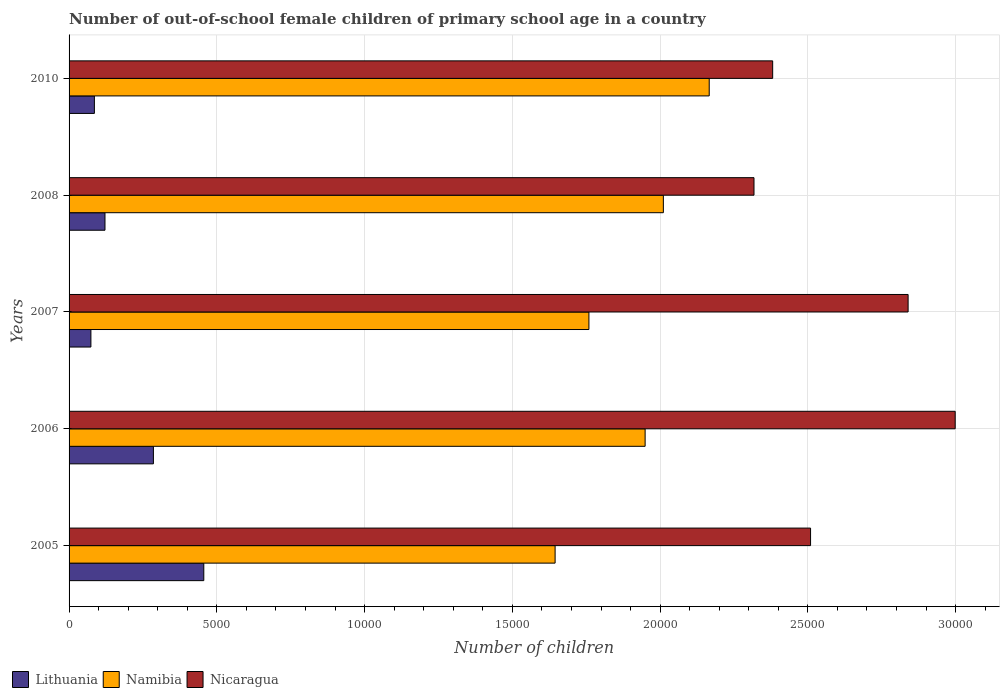How many different coloured bars are there?
Offer a very short reply. 3. Are the number of bars per tick equal to the number of legend labels?
Your response must be concise. Yes. How many bars are there on the 1st tick from the bottom?
Your answer should be compact. 3. What is the label of the 1st group of bars from the top?
Offer a very short reply. 2010. What is the number of out-of-school female children in Nicaragua in 2007?
Your answer should be very brief. 2.84e+04. Across all years, what is the maximum number of out-of-school female children in Lithuania?
Your answer should be compact. 4559. Across all years, what is the minimum number of out-of-school female children in Nicaragua?
Give a very brief answer. 2.32e+04. In which year was the number of out-of-school female children in Lithuania maximum?
Offer a very short reply. 2005. What is the total number of out-of-school female children in Namibia in the graph?
Ensure brevity in your answer.  9.53e+04. What is the difference between the number of out-of-school female children in Namibia in 2005 and that in 2010?
Give a very brief answer. -5215. What is the difference between the number of out-of-school female children in Namibia in 2010 and the number of out-of-school female children in Lithuania in 2005?
Your response must be concise. 1.71e+04. What is the average number of out-of-school female children in Lithuania per year?
Ensure brevity in your answer.  2044.8. In the year 2010, what is the difference between the number of out-of-school female children in Nicaragua and number of out-of-school female children in Lithuania?
Provide a succinct answer. 2.30e+04. What is the ratio of the number of out-of-school female children in Nicaragua in 2005 to that in 2010?
Provide a short and direct response. 1.05. What is the difference between the highest and the second highest number of out-of-school female children in Lithuania?
Your answer should be compact. 1705. What is the difference between the highest and the lowest number of out-of-school female children in Lithuania?
Keep it short and to the point. 3820. In how many years, is the number of out-of-school female children in Lithuania greater than the average number of out-of-school female children in Lithuania taken over all years?
Your answer should be very brief. 2. Is the sum of the number of out-of-school female children in Lithuania in 2005 and 2007 greater than the maximum number of out-of-school female children in Namibia across all years?
Give a very brief answer. No. What does the 1st bar from the top in 2006 represents?
Your answer should be very brief. Nicaragua. What does the 3rd bar from the bottom in 2008 represents?
Provide a succinct answer. Nicaragua. Are all the bars in the graph horizontal?
Your answer should be compact. Yes. What is the difference between two consecutive major ticks on the X-axis?
Your answer should be very brief. 5000. Are the values on the major ticks of X-axis written in scientific E-notation?
Offer a terse response. No. How many legend labels are there?
Offer a terse response. 3. What is the title of the graph?
Offer a very short reply. Number of out-of-school female children of primary school age in a country. Does "Gabon" appear as one of the legend labels in the graph?
Keep it short and to the point. No. What is the label or title of the X-axis?
Provide a short and direct response. Number of children. What is the label or title of the Y-axis?
Provide a succinct answer. Years. What is the Number of children in Lithuania in 2005?
Your answer should be very brief. 4559. What is the Number of children in Namibia in 2005?
Give a very brief answer. 1.64e+04. What is the Number of children in Nicaragua in 2005?
Offer a very short reply. 2.51e+04. What is the Number of children in Lithuania in 2006?
Ensure brevity in your answer.  2854. What is the Number of children in Namibia in 2006?
Make the answer very short. 1.95e+04. What is the Number of children in Nicaragua in 2006?
Offer a terse response. 3.00e+04. What is the Number of children in Lithuania in 2007?
Keep it short and to the point. 739. What is the Number of children of Namibia in 2007?
Give a very brief answer. 1.76e+04. What is the Number of children of Nicaragua in 2007?
Provide a short and direct response. 2.84e+04. What is the Number of children in Lithuania in 2008?
Ensure brevity in your answer.  1215. What is the Number of children in Namibia in 2008?
Provide a succinct answer. 2.01e+04. What is the Number of children of Nicaragua in 2008?
Offer a very short reply. 2.32e+04. What is the Number of children of Lithuania in 2010?
Give a very brief answer. 857. What is the Number of children in Namibia in 2010?
Provide a succinct answer. 2.17e+04. What is the Number of children in Nicaragua in 2010?
Your answer should be compact. 2.38e+04. Across all years, what is the maximum Number of children in Lithuania?
Provide a short and direct response. 4559. Across all years, what is the maximum Number of children in Namibia?
Your answer should be compact. 2.17e+04. Across all years, what is the maximum Number of children in Nicaragua?
Offer a very short reply. 3.00e+04. Across all years, what is the minimum Number of children of Lithuania?
Ensure brevity in your answer.  739. Across all years, what is the minimum Number of children of Namibia?
Your answer should be compact. 1.64e+04. Across all years, what is the minimum Number of children of Nicaragua?
Offer a terse response. 2.32e+04. What is the total Number of children in Lithuania in the graph?
Your answer should be compact. 1.02e+04. What is the total Number of children in Namibia in the graph?
Provide a succinct answer. 9.53e+04. What is the total Number of children of Nicaragua in the graph?
Ensure brevity in your answer.  1.30e+05. What is the difference between the Number of children of Lithuania in 2005 and that in 2006?
Keep it short and to the point. 1705. What is the difference between the Number of children in Namibia in 2005 and that in 2006?
Make the answer very short. -3046. What is the difference between the Number of children of Nicaragua in 2005 and that in 2006?
Offer a very short reply. -4894. What is the difference between the Number of children in Lithuania in 2005 and that in 2007?
Provide a succinct answer. 3820. What is the difference between the Number of children in Namibia in 2005 and that in 2007?
Give a very brief answer. -1144. What is the difference between the Number of children in Nicaragua in 2005 and that in 2007?
Your answer should be compact. -3301. What is the difference between the Number of children in Lithuania in 2005 and that in 2008?
Make the answer very short. 3344. What is the difference between the Number of children in Namibia in 2005 and that in 2008?
Your answer should be very brief. -3663. What is the difference between the Number of children of Nicaragua in 2005 and that in 2008?
Provide a short and direct response. 1914. What is the difference between the Number of children in Lithuania in 2005 and that in 2010?
Your answer should be very brief. 3702. What is the difference between the Number of children of Namibia in 2005 and that in 2010?
Make the answer very short. -5215. What is the difference between the Number of children of Nicaragua in 2005 and that in 2010?
Give a very brief answer. 1282. What is the difference between the Number of children of Lithuania in 2006 and that in 2007?
Provide a succinct answer. 2115. What is the difference between the Number of children of Namibia in 2006 and that in 2007?
Keep it short and to the point. 1902. What is the difference between the Number of children in Nicaragua in 2006 and that in 2007?
Make the answer very short. 1593. What is the difference between the Number of children of Lithuania in 2006 and that in 2008?
Your response must be concise. 1639. What is the difference between the Number of children in Namibia in 2006 and that in 2008?
Give a very brief answer. -617. What is the difference between the Number of children of Nicaragua in 2006 and that in 2008?
Give a very brief answer. 6808. What is the difference between the Number of children in Lithuania in 2006 and that in 2010?
Your answer should be very brief. 1997. What is the difference between the Number of children of Namibia in 2006 and that in 2010?
Keep it short and to the point. -2169. What is the difference between the Number of children in Nicaragua in 2006 and that in 2010?
Ensure brevity in your answer.  6176. What is the difference between the Number of children of Lithuania in 2007 and that in 2008?
Provide a short and direct response. -476. What is the difference between the Number of children of Namibia in 2007 and that in 2008?
Make the answer very short. -2519. What is the difference between the Number of children of Nicaragua in 2007 and that in 2008?
Keep it short and to the point. 5215. What is the difference between the Number of children of Lithuania in 2007 and that in 2010?
Your answer should be compact. -118. What is the difference between the Number of children of Namibia in 2007 and that in 2010?
Make the answer very short. -4071. What is the difference between the Number of children of Nicaragua in 2007 and that in 2010?
Your answer should be compact. 4583. What is the difference between the Number of children in Lithuania in 2008 and that in 2010?
Keep it short and to the point. 358. What is the difference between the Number of children in Namibia in 2008 and that in 2010?
Keep it short and to the point. -1552. What is the difference between the Number of children in Nicaragua in 2008 and that in 2010?
Provide a succinct answer. -632. What is the difference between the Number of children of Lithuania in 2005 and the Number of children of Namibia in 2006?
Your answer should be very brief. -1.49e+04. What is the difference between the Number of children of Lithuania in 2005 and the Number of children of Nicaragua in 2006?
Offer a terse response. -2.54e+04. What is the difference between the Number of children of Namibia in 2005 and the Number of children of Nicaragua in 2006?
Provide a succinct answer. -1.35e+04. What is the difference between the Number of children of Lithuania in 2005 and the Number of children of Namibia in 2007?
Keep it short and to the point. -1.30e+04. What is the difference between the Number of children of Lithuania in 2005 and the Number of children of Nicaragua in 2007?
Make the answer very short. -2.38e+04. What is the difference between the Number of children of Namibia in 2005 and the Number of children of Nicaragua in 2007?
Ensure brevity in your answer.  -1.19e+04. What is the difference between the Number of children of Lithuania in 2005 and the Number of children of Namibia in 2008?
Offer a terse response. -1.56e+04. What is the difference between the Number of children of Lithuania in 2005 and the Number of children of Nicaragua in 2008?
Keep it short and to the point. -1.86e+04. What is the difference between the Number of children of Namibia in 2005 and the Number of children of Nicaragua in 2008?
Make the answer very short. -6730. What is the difference between the Number of children of Lithuania in 2005 and the Number of children of Namibia in 2010?
Keep it short and to the point. -1.71e+04. What is the difference between the Number of children of Lithuania in 2005 and the Number of children of Nicaragua in 2010?
Your answer should be very brief. -1.92e+04. What is the difference between the Number of children in Namibia in 2005 and the Number of children in Nicaragua in 2010?
Provide a succinct answer. -7362. What is the difference between the Number of children of Lithuania in 2006 and the Number of children of Namibia in 2007?
Make the answer very short. -1.47e+04. What is the difference between the Number of children of Lithuania in 2006 and the Number of children of Nicaragua in 2007?
Offer a terse response. -2.55e+04. What is the difference between the Number of children of Namibia in 2006 and the Number of children of Nicaragua in 2007?
Ensure brevity in your answer.  -8899. What is the difference between the Number of children of Lithuania in 2006 and the Number of children of Namibia in 2008?
Offer a terse response. -1.73e+04. What is the difference between the Number of children of Lithuania in 2006 and the Number of children of Nicaragua in 2008?
Provide a succinct answer. -2.03e+04. What is the difference between the Number of children in Namibia in 2006 and the Number of children in Nicaragua in 2008?
Provide a succinct answer. -3684. What is the difference between the Number of children of Lithuania in 2006 and the Number of children of Namibia in 2010?
Make the answer very short. -1.88e+04. What is the difference between the Number of children of Lithuania in 2006 and the Number of children of Nicaragua in 2010?
Give a very brief answer. -2.10e+04. What is the difference between the Number of children in Namibia in 2006 and the Number of children in Nicaragua in 2010?
Provide a short and direct response. -4316. What is the difference between the Number of children in Lithuania in 2007 and the Number of children in Namibia in 2008?
Your response must be concise. -1.94e+04. What is the difference between the Number of children in Lithuania in 2007 and the Number of children in Nicaragua in 2008?
Offer a terse response. -2.24e+04. What is the difference between the Number of children of Namibia in 2007 and the Number of children of Nicaragua in 2008?
Keep it short and to the point. -5586. What is the difference between the Number of children of Lithuania in 2007 and the Number of children of Namibia in 2010?
Make the answer very short. -2.09e+04. What is the difference between the Number of children in Lithuania in 2007 and the Number of children in Nicaragua in 2010?
Ensure brevity in your answer.  -2.31e+04. What is the difference between the Number of children of Namibia in 2007 and the Number of children of Nicaragua in 2010?
Your answer should be compact. -6218. What is the difference between the Number of children of Lithuania in 2008 and the Number of children of Namibia in 2010?
Your response must be concise. -2.04e+04. What is the difference between the Number of children in Lithuania in 2008 and the Number of children in Nicaragua in 2010?
Provide a short and direct response. -2.26e+04. What is the difference between the Number of children in Namibia in 2008 and the Number of children in Nicaragua in 2010?
Offer a terse response. -3699. What is the average Number of children in Lithuania per year?
Your answer should be very brief. 2044.8. What is the average Number of children in Namibia per year?
Ensure brevity in your answer.  1.91e+04. What is the average Number of children of Nicaragua per year?
Your answer should be compact. 2.61e+04. In the year 2005, what is the difference between the Number of children in Lithuania and Number of children in Namibia?
Provide a short and direct response. -1.19e+04. In the year 2005, what is the difference between the Number of children in Lithuania and Number of children in Nicaragua?
Keep it short and to the point. -2.05e+04. In the year 2005, what is the difference between the Number of children in Namibia and Number of children in Nicaragua?
Your answer should be very brief. -8644. In the year 2006, what is the difference between the Number of children in Lithuania and Number of children in Namibia?
Ensure brevity in your answer.  -1.66e+04. In the year 2006, what is the difference between the Number of children in Lithuania and Number of children in Nicaragua?
Keep it short and to the point. -2.71e+04. In the year 2006, what is the difference between the Number of children in Namibia and Number of children in Nicaragua?
Offer a terse response. -1.05e+04. In the year 2007, what is the difference between the Number of children of Lithuania and Number of children of Namibia?
Keep it short and to the point. -1.69e+04. In the year 2007, what is the difference between the Number of children of Lithuania and Number of children of Nicaragua?
Give a very brief answer. -2.77e+04. In the year 2007, what is the difference between the Number of children of Namibia and Number of children of Nicaragua?
Provide a succinct answer. -1.08e+04. In the year 2008, what is the difference between the Number of children in Lithuania and Number of children in Namibia?
Make the answer very short. -1.89e+04. In the year 2008, what is the difference between the Number of children of Lithuania and Number of children of Nicaragua?
Offer a very short reply. -2.20e+04. In the year 2008, what is the difference between the Number of children in Namibia and Number of children in Nicaragua?
Give a very brief answer. -3067. In the year 2010, what is the difference between the Number of children in Lithuania and Number of children in Namibia?
Your answer should be compact. -2.08e+04. In the year 2010, what is the difference between the Number of children in Lithuania and Number of children in Nicaragua?
Make the answer very short. -2.30e+04. In the year 2010, what is the difference between the Number of children in Namibia and Number of children in Nicaragua?
Your answer should be compact. -2147. What is the ratio of the Number of children in Lithuania in 2005 to that in 2006?
Offer a terse response. 1.6. What is the ratio of the Number of children of Namibia in 2005 to that in 2006?
Your response must be concise. 0.84. What is the ratio of the Number of children of Nicaragua in 2005 to that in 2006?
Offer a terse response. 0.84. What is the ratio of the Number of children of Lithuania in 2005 to that in 2007?
Your response must be concise. 6.17. What is the ratio of the Number of children of Namibia in 2005 to that in 2007?
Ensure brevity in your answer.  0.94. What is the ratio of the Number of children of Nicaragua in 2005 to that in 2007?
Your answer should be very brief. 0.88. What is the ratio of the Number of children of Lithuania in 2005 to that in 2008?
Your answer should be very brief. 3.75. What is the ratio of the Number of children of Namibia in 2005 to that in 2008?
Keep it short and to the point. 0.82. What is the ratio of the Number of children of Nicaragua in 2005 to that in 2008?
Your response must be concise. 1.08. What is the ratio of the Number of children of Lithuania in 2005 to that in 2010?
Make the answer very short. 5.32. What is the ratio of the Number of children of Namibia in 2005 to that in 2010?
Make the answer very short. 0.76. What is the ratio of the Number of children in Nicaragua in 2005 to that in 2010?
Ensure brevity in your answer.  1.05. What is the ratio of the Number of children in Lithuania in 2006 to that in 2007?
Keep it short and to the point. 3.86. What is the ratio of the Number of children of Namibia in 2006 to that in 2007?
Provide a short and direct response. 1.11. What is the ratio of the Number of children of Nicaragua in 2006 to that in 2007?
Your answer should be very brief. 1.06. What is the ratio of the Number of children in Lithuania in 2006 to that in 2008?
Ensure brevity in your answer.  2.35. What is the ratio of the Number of children in Namibia in 2006 to that in 2008?
Your answer should be compact. 0.97. What is the ratio of the Number of children of Nicaragua in 2006 to that in 2008?
Give a very brief answer. 1.29. What is the ratio of the Number of children of Lithuania in 2006 to that in 2010?
Provide a short and direct response. 3.33. What is the ratio of the Number of children of Namibia in 2006 to that in 2010?
Your answer should be compact. 0.9. What is the ratio of the Number of children in Nicaragua in 2006 to that in 2010?
Give a very brief answer. 1.26. What is the ratio of the Number of children of Lithuania in 2007 to that in 2008?
Offer a terse response. 0.61. What is the ratio of the Number of children in Namibia in 2007 to that in 2008?
Give a very brief answer. 0.87. What is the ratio of the Number of children in Nicaragua in 2007 to that in 2008?
Provide a short and direct response. 1.23. What is the ratio of the Number of children of Lithuania in 2007 to that in 2010?
Give a very brief answer. 0.86. What is the ratio of the Number of children of Namibia in 2007 to that in 2010?
Ensure brevity in your answer.  0.81. What is the ratio of the Number of children of Nicaragua in 2007 to that in 2010?
Keep it short and to the point. 1.19. What is the ratio of the Number of children of Lithuania in 2008 to that in 2010?
Provide a succinct answer. 1.42. What is the ratio of the Number of children in Namibia in 2008 to that in 2010?
Give a very brief answer. 0.93. What is the ratio of the Number of children in Nicaragua in 2008 to that in 2010?
Your response must be concise. 0.97. What is the difference between the highest and the second highest Number of children of Lithuania?
Your answer should be very brief. 1705. What is the difference between the highest and the second highest Number of children in Namibia?
Make the answer very short. 1552. What is the difference between the highest and the second highest Number of children in Nicaragua?
Give a very brief answer. 1593. What is the difference between the highest and the lowest Number of children of Lithuania?
Provide a succinct answer. 3820. What is the difference between the highest and the lowest Number of children of Namibia?
Provide a short and direct response. 5215. What is the difference between the highest and the lowest Number of children of Nicaragua?
Offer a terse response. 6808. 